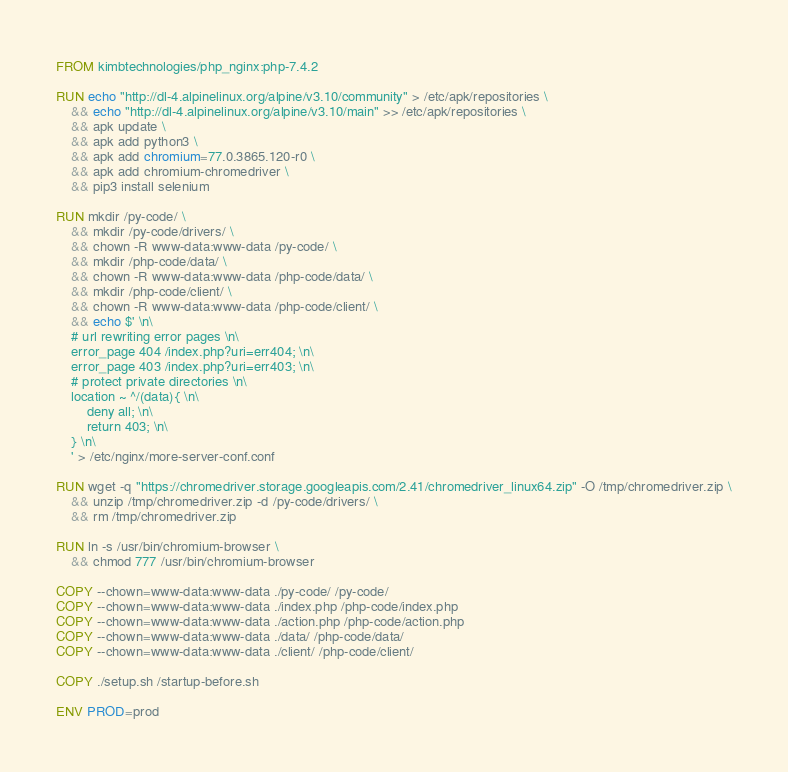<code> <loc_0><loc_0><loc_500><loc_500><_Dockerfile_>FROM kimbtechnologies/php_nginx:php-7.4.2

RUN echo "http://dl-4.alpinelinux.org/alpine/v3.10/community" > /etc/apk/repositories \
	&& echo "http://dl-4.alpinelinux.org/alpine/v3.10/main" >> /etc/apk/repositories \
	&& apk update \
	&& apk add python3 \
	&& apk add chromium=77.0.3865.120-r0 \
	&& apk add chromium-chromedriver \
	&& pip3 install selenium 

RUN mkdir /py-code/ \
	&& mkdir /py-code/drivers/ \
	&& chown -R www-data:www-data /py-code/ \
	&& mkdir /php-code/data/ \
	&& chown -R www-data:www-data /php-code/data/ \
	&& mkdir /php-code/client/ \
	&& chown -R www-data:www-data /php-code/client/ \
	&& echo $' \n\
	# url rewriting error pages \n\
	error_page 404 /index.php?uri=err404; \n\
	error_page 403 /index.php?uri=err403; \n\
	# protect private directories \n\
	location ~ ^/(data){ \n\
		deny all; \n\
		return 403; \n\
	} \n\
	' > /etc/nginx/more-server-conf.conf

RUN wget -q "https://chromedriver.storage.googleapis.com/2.41/chromedriver_linux64.zip" -O /tmp/chromedriver.zip \
    && unzip /tmp/chromedriver.zip -d /py-code/drivers/ \
    && rm /tmp/chromedriver.zip

RUN ln -s /usr/bin/chromium-browser \
    && chmod 777 /usr/bin/chromium-browser

COPY --chown=www-data:www-data ./py-code/ /py-code/
COPY --chown=www-data:www-data ./index.php /php-code/index.php
COPY --chown=www-data:www-data ./action.php /php-code/action.php
COPY --chown=www-data:www-data ./data/ /php-code/data/
COPY --chown=www-data:www-data ./client/ /php-code/client/

COPY ./setup.sh /startup-before.sh

ENV PROD=prod
</code> 